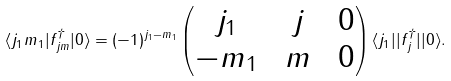Convert formula to latex. <formula><loc_0><loc_0><loc_500><loc_500>\langle j _ { 1 } m _ { 1 } | f _ { j m } ^ { \dagger } | 0 \rangle = ( - 1 ) ^ { j _ { 1 } - m _ { 1 } } \begin{pmatrix} j _ { 1 } \, & \, j \, & \, 0 \\ - m _ { 1 } \, & \, m \, & \, 0 \end{pmatrix} \langle j _ { 1 } | | f _ { j } ^ { \dagger } | | 0 \rangle .</formula> 